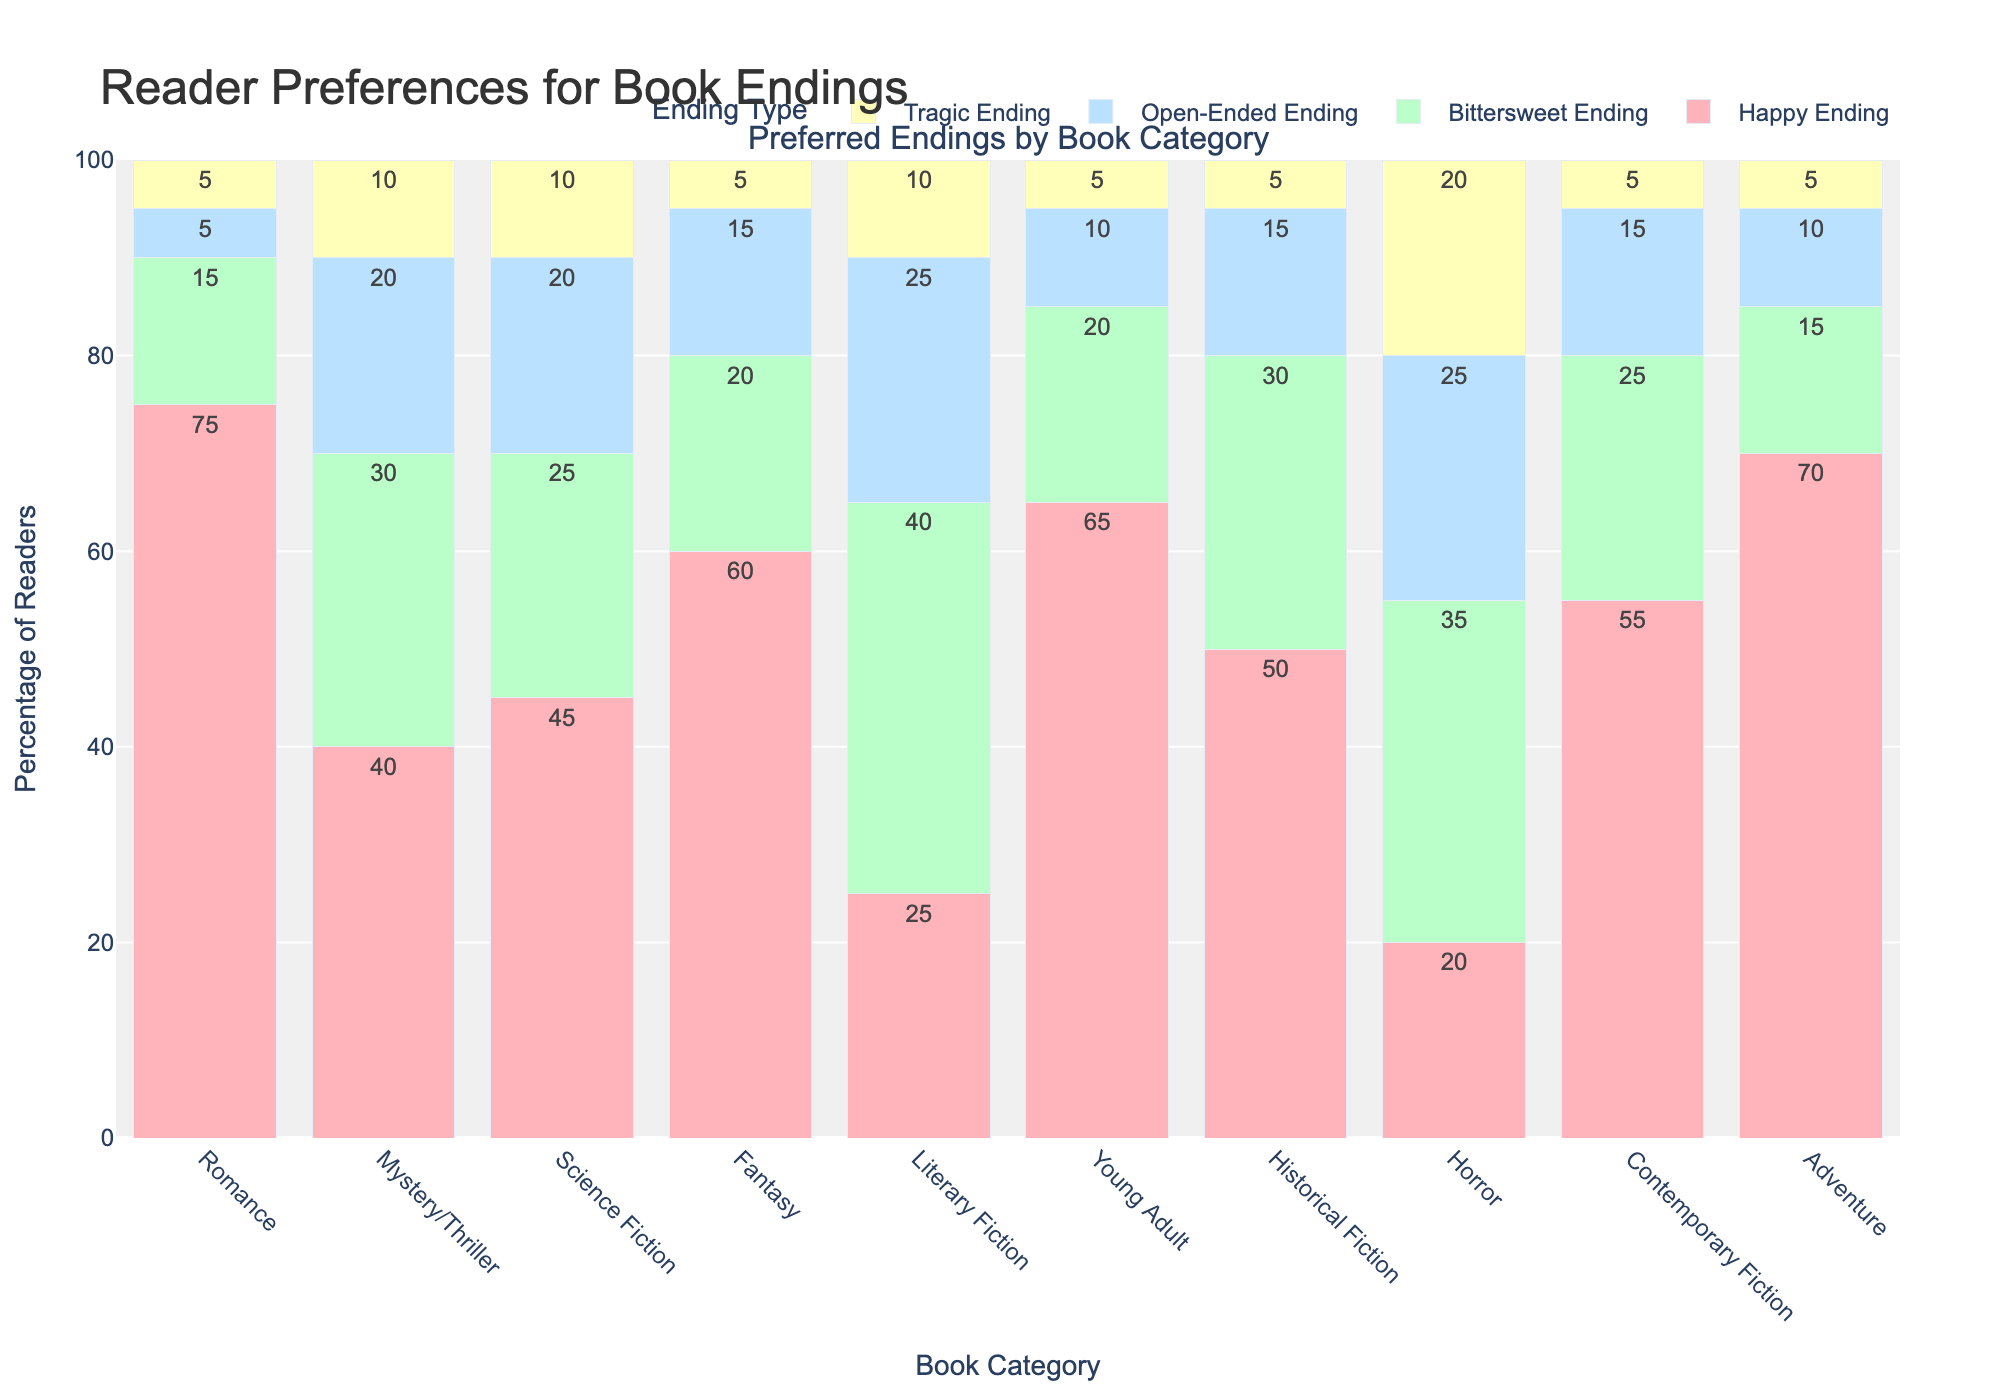What percentage of readers prefer a happy ending in Romance novels compared to Mystery/Thriller novels? Romance has 75% for happy endings while Mystery/Thriller has 40%. The comparison shows that Romance has a higher percentage by 35%.
Answer: Romance by 35% Which book category has the highest preference for bittersweet endings? Literary Fiction has the highest percentage of readers who prefer bittersweet endings at 40%.
Answer: Literary Fiction What is the combined percentage of readers who prefer either open-ended or tragic endings in Science Fiction books? Add the percentages of open-ended (20%) and tragic (10%) endings in Science Fiction: 20% + 10% = 30%.
Answer: 30% How many book categories have a higher preference for tragic endings than for happy endings? Tragic endings have higher percentages than happy endings in Horror, but not in any other category. Hence, only Horror applies.
Answer: 1 (Horror) In which book categories do more than 50% of readers prefer a happy ending? The categories where more than 50% of readers prefer happy endings are Romance (75%), Fantasy (60%), Young Adult (65%), Contemporary Fiction (55%), and Adventure (70%).
Answer: 5 categories What is the difference in preference for open-ended endings between Fantasy and Horror books? Fantasy has a 15% preference for open-ended endings whereas Horror has 25%. The difference is 25 - 15 = 10%.
Answer: 10% Which category has the closest percentages for happy and bittersweet endings? Science Fiction has 45% for happy endings and 25% for bittersweet endings, a difference of 20%. Compared to other categories, this gap is the smallest.
Answer: Science Fiction What percentage of readers prefer an open-ended or tragic ending in Mystery/Thriller books? Combining the percentages for open-ended (20%) and tragic (10%) endings in Mystery/Thriller: 20% + 10% = 30%.
Answer: 30% In which category do readers show a 20% preference for bittersweet endings? Both Fantasy and Young Adult have a 20% preference for bittersweet endings.
Answer: Fantasy and Young Adult What is the total percentage of all endings other than happy endings in Romance novels? Combining the percentages of bittersweet (15%), open-ended (5%), and tragic (5%) endings in Romance: 15% + 5% + 5% = 25%.
Answer: 25% 